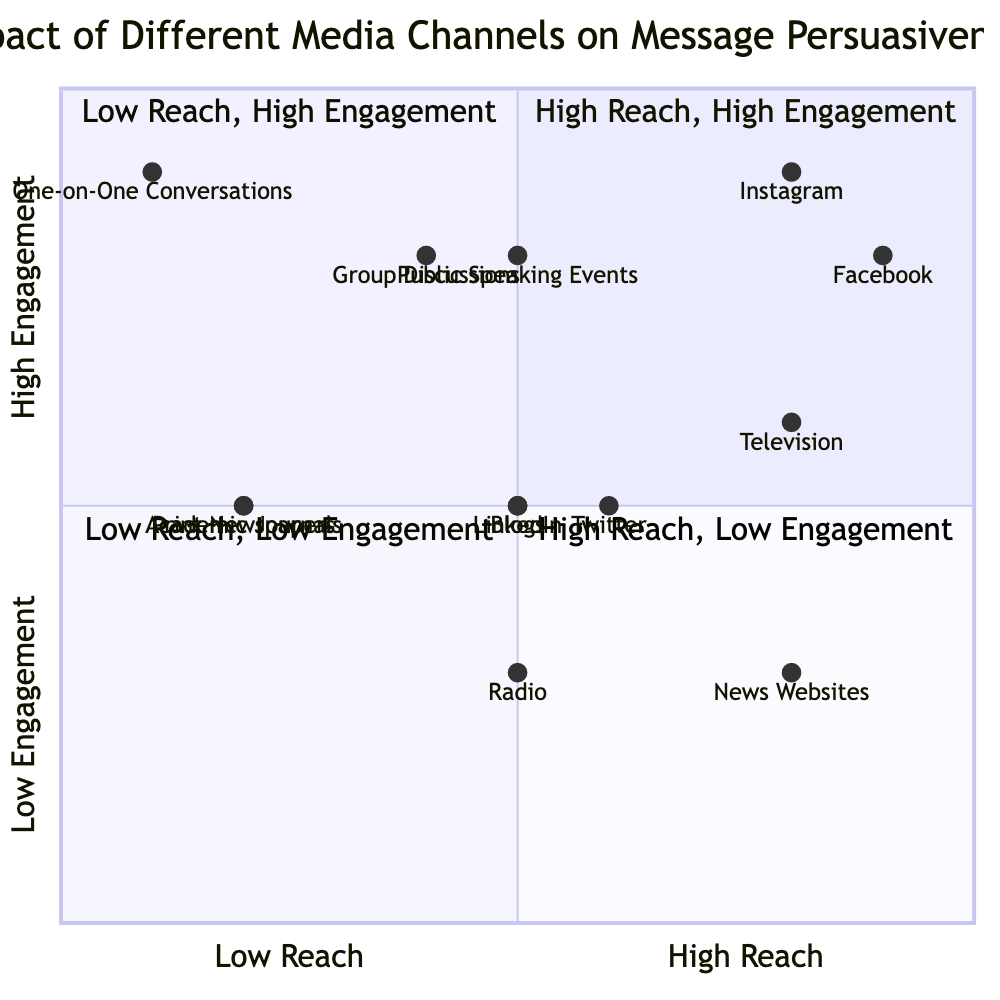What media channel has the highest reach and engagement? By examining the quadrant where both reach and engagement values are high, we find that Facebook and Instagram are located here. Among these, Facebook has a slightly lower engagement than Instagram but has high reach. However, the question directly asks for the highest, which is Instagram with both reach and engagement being high.
Answer: Instagram Which media channel has the lowest engagement? Looking at the engagement values of all the channels, we observe that Radio has the lowest engagement value of low within its quadrant. Comparing across quadrants, News Websites have low engagement as well, but since Radio pertains to traditional media, it is consistent across its category.
Answer: Radio How many media channels are located in the high reach and low engagement quadrant? To determine the number of channels in the high reach and low engagement quadrant, we look for nodes specifically given for this quadrant. In this case, two channels fall into this category: Television and News Websites. Thus, it totals to two channels.
Answer: 2 What is the engagement level of Public Speaking Events? Looking specifically at the point representing Public Speaking Events, we can directly observe its engagement value, which is categorized as high.
Answer: High Which media channel has high credibility but low reach? Analyzing the credibility values associated with low reach channels, we find that Print Newspapers and Academic Journals both exhibit high credibility. However, Print Newspapers are distinctly classified under low reach quantitatively, making it the valid answer here as it has low reach despite high credibility.
Answer: Print Newspapers What is the reach value for Instagram? Referring to the data point for Instagram in the quadrant, it clearly shows a high reach value, specifically quantified as high.
Answer: High Which media channel has the same engagement level as Blogs but lower reach? In reviewing the engagement level of Blogs, which is medium, we can see that Radio also possesses medium engagement but has lower reach quantified as medium compared to Blogs' reach. Liquidating them from high and low, the contrast confirms the answer.
Answer: Radio How many media channels are in the low reach and high engagement quadrant? Identifying the channels on the quadrant focused on low reach and high engagement, we observe that there are three channels: One-on-One Conversations, Public Speaking Events, and Group Discussions. Therefore, this sums up to a count of three.
Answer: 3 Which channel has the highest credibility in the Social Media quadrant? When analyzing credibility values within the Social Media category, we find that LinkedIn has high credibility, making it stand out relative to others such as Facebook, Instagram, and Twitter, which have medium to low credibility.
Answer: LinkedIn 